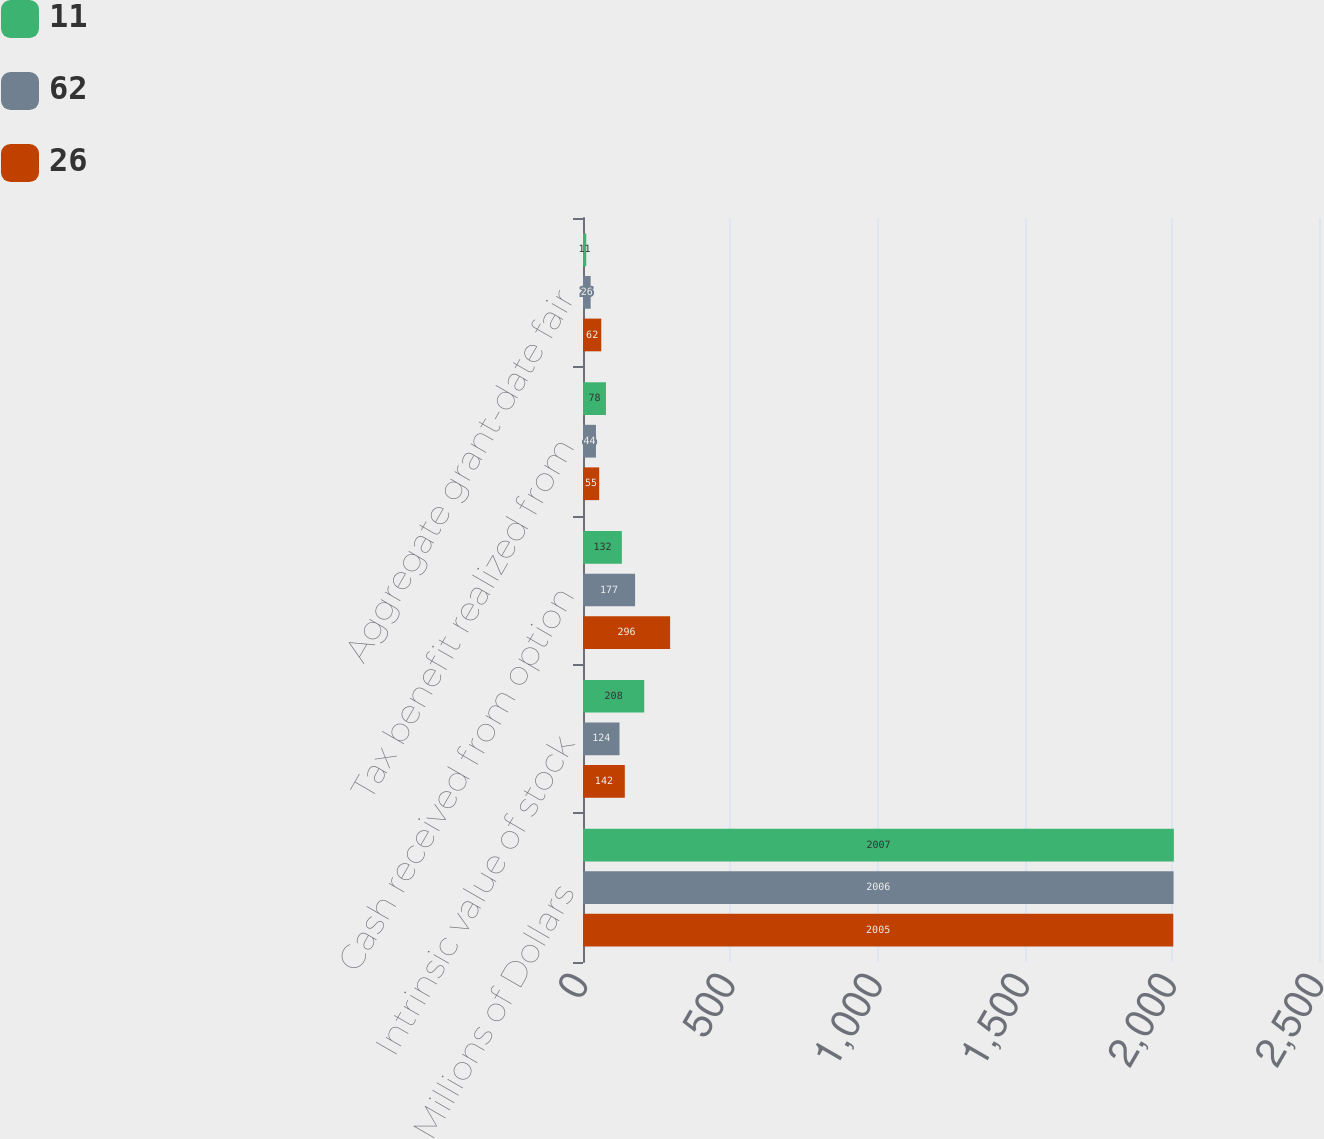Convert chart. <chart><loc_0><loc_0><loc_500><loc_500><stacked_bar_chart><ecel><fcel>Millions of Dollars<fcel>Intrinsic value of stock<fcel>Cash received from option<fcel>Tax benefit realized from<fcel>Aggregate grant-date fair<nl><fcel>11<fcel>2007<fcel>208<fcel>132<fcel>78<fcel>11<nl><fcel>62<fcel>2006<fcel>124<fcel>177<fcel>44<fcel>26<nl><fcel>26<fcel>2005<fcel>142<fcel>296<fcel>55<fcel>62<nl></chart> 